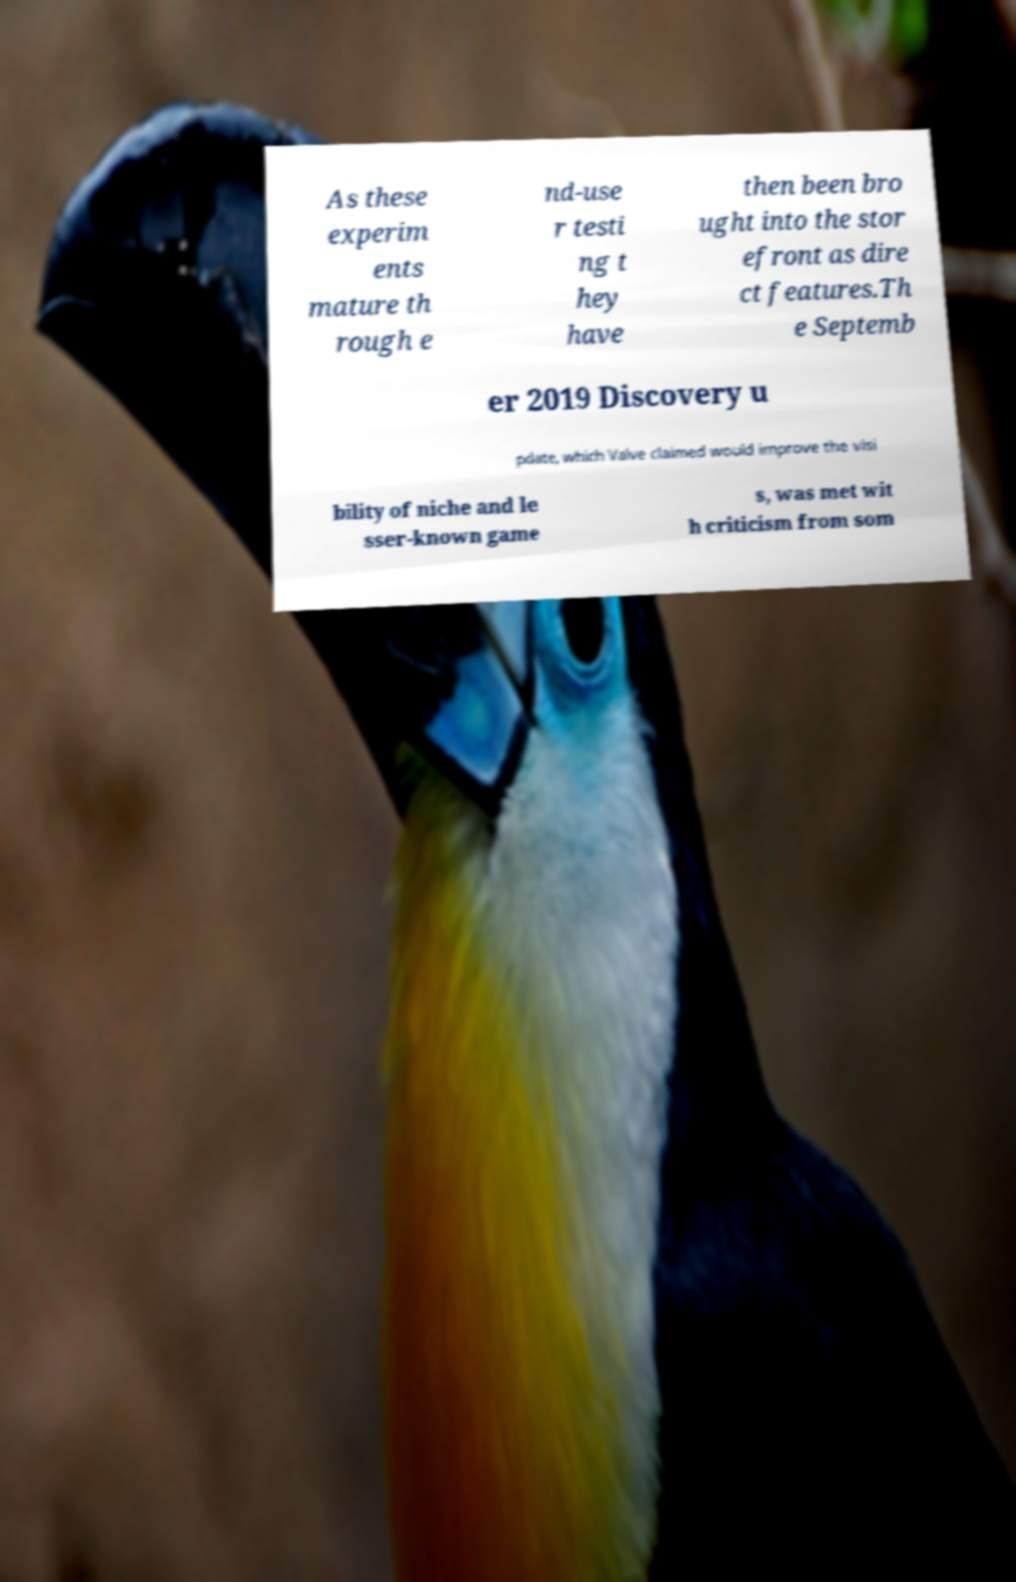I need the written content from this picture converted into text. Can you do that? As these experim ents mature th rough e nd-use r testi ng t hey have then been bro ught into the stor efront as dire ct features.Th e Septemb er 2019 Discovery u pdate, which Valve claimed would improve the visi bility of niche and le sser-known game s, was met wit h criticism from som 